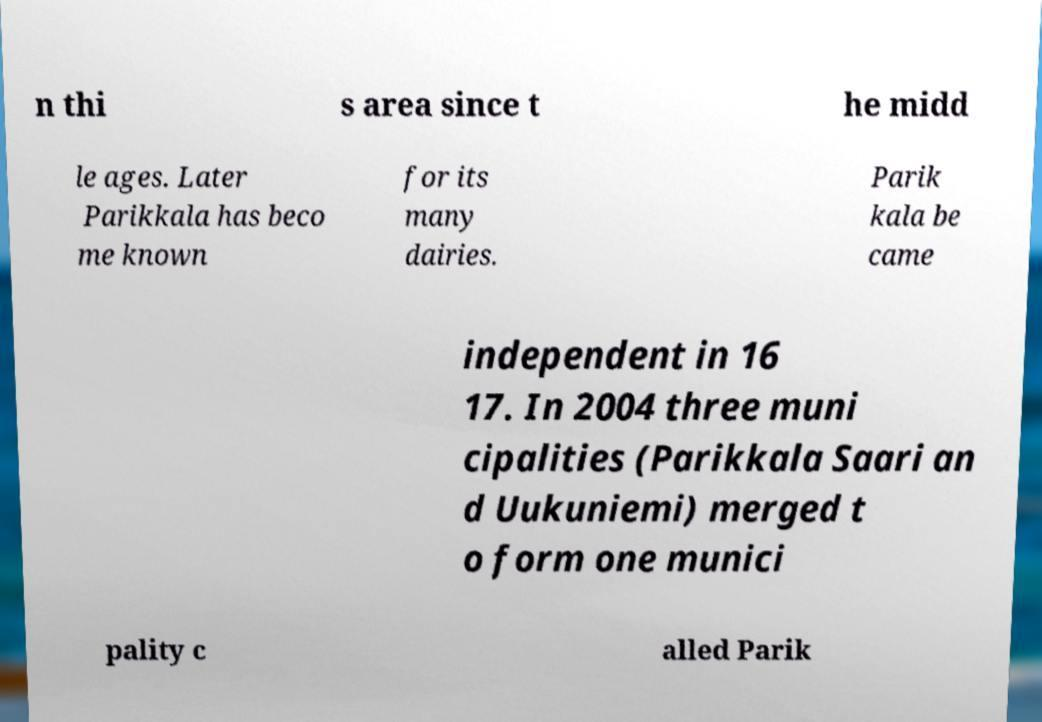Please identify and transcribe the text found in this image. n thi s area since t he midd le ages. Later Parikkala has beco me known for its many dairies. Parik kala be came independent in 16 17. In 2004 three muni cipalities (Parikkala Saari an d Uukuniemi) merged t o form one munici pality c alled Parik 